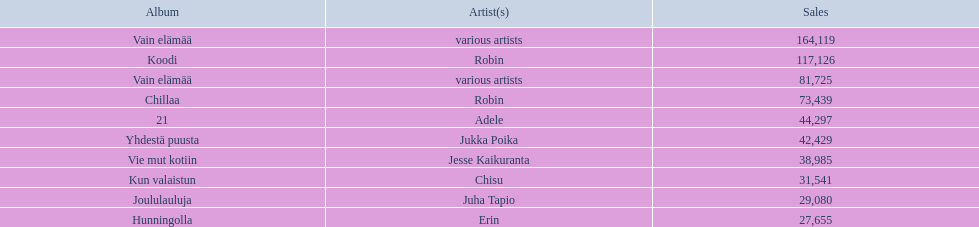Who is the artist for 21 album? Adele. Give me the full table as a dictionary. {'header': ['Album', 'Artist(s)', 'Sales'], 'rows': [['Vain elämää', 'various artists', '164,119'], ['Koodi', 'Robin', '117,126'], ['Vain elämää', 'various artists', '81,725'], ['Chillaa', 'Robin', '73,439'], ['21', 'Adele', '44,297'], ['Yhdestä puusta', 'Jukka Poika', '42,429'], ['Vie mut kotiin', 'Jesse Kaikuranta', '38,985'], ['Kun valaistun', 'Chisu', '31,541'], ['Joululauluja', 'Juha Tapio', '29,080'], ['Hunningolla', 'Erin', '27,655']]} Who is the artist for kun valaistun? Chisu. Which album had the same artist as chillaa? Koodi. 